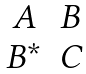Convert formula to latex. <formula><loc_0><loc_0><loc_500><loc_500>\begin{matrix} A & B \\ B ^ { * } & C \end{matrix}</formula> 